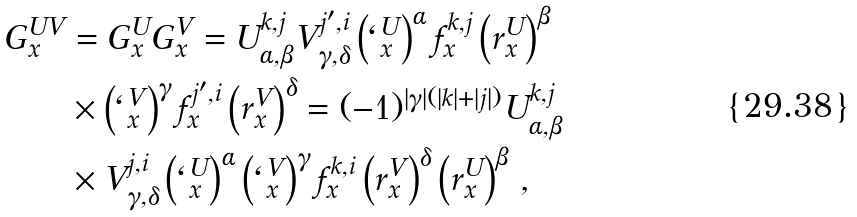Convert formula to latex. <formula><loc_0><loc_0><loc_500><loc_500>G ^ { U V } _ { x } & = G ^ { U } _ { x } G ^ { V } _ { x } = U ^ { k , j } _ { \alpha , \beta } V ^ { j ^ { \prime } , i } _ { \gamma , \delta } \left ( \ell _ { x } ^ { U } \right ) ^ { \alpha } f _ { x } ^ { k , j } \left ( r _ { x } ^ { U } \right ) ^ { \beta } \\ & \times \left ( \ell _ { x } ^ { V } \right ) ^ { \gamma } f _ { x } ^ { j ^ { \prime } , i } \left ( r _ { x } ^ { V } \right ) ^ { \delta } = ( - 1 ) ^ { | \gamma | ( | k | + | j | ) } U ^ { k , j } _ { \alpha , \beta } \\ & \times V ^ { j , i } _ { \gamma , \delta } \left ( \ell _ { x } ^ { U } \right ) ^ { \alpha } \left ( \ell _ { x } ^ { V } \right ) ^ { \gamma } f _ { x } ^ { k , i } \left ( r ^ { V } _ { x } \right ) ^ { \delta } \left ( r ^ { U } _ { x } \right ) ^ { \beta } \, ,</formula> 